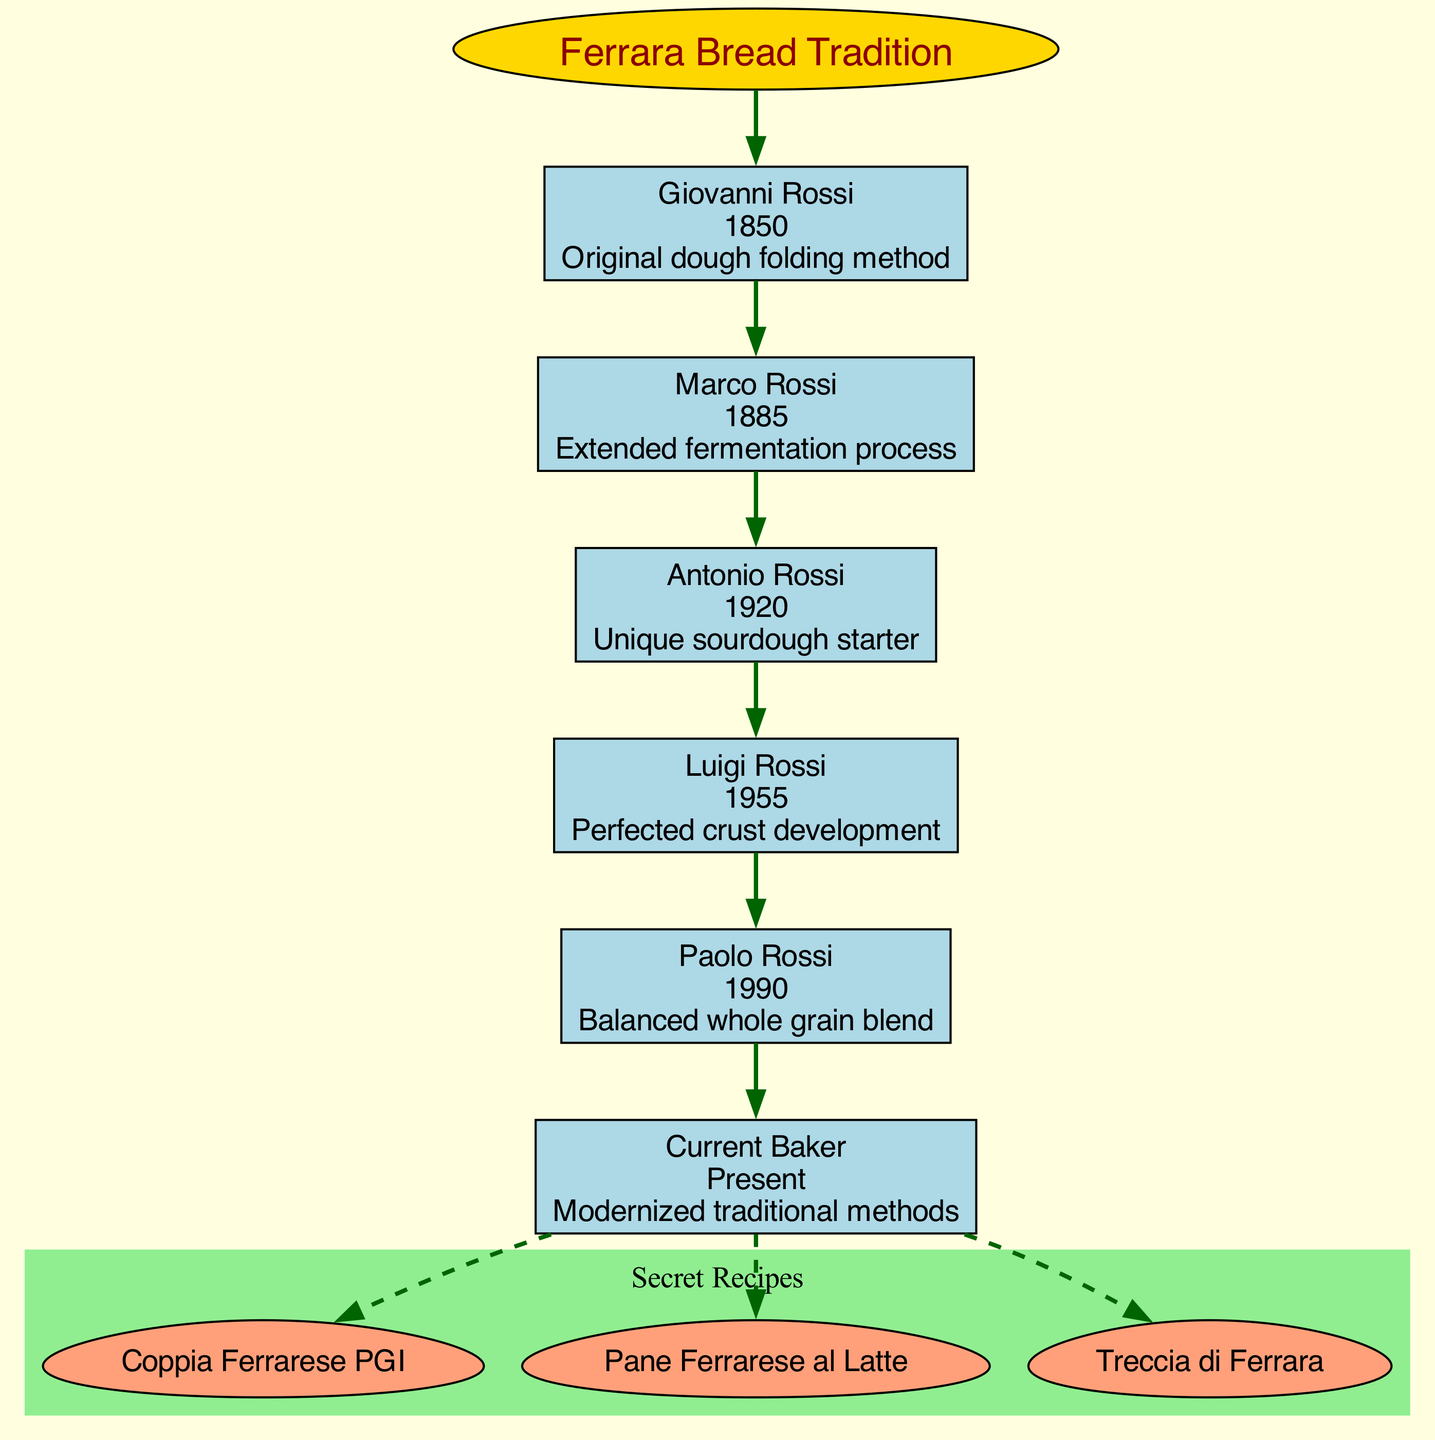What is the technique used by Giovanni Rossi? Giovanni Rossi is at the top of the lineage in the diagram, and the technique associated with him is "Original dough folding method."
Answer: Original dough folding method What year did Marco Rossi contribute his technique? By examining the node for Marco Rossi, it indicates that he contributed his technique in the year 1885.
Answer: 1885 How many secret recipes are listed in the diagram? The diagram includes three secret recipes underneath the "Secret Recipes" cluster, which can be counted visually.
Answer: 3 Which technique was perfected by Luigi Rossi? Luigi Rossi's node indicates that he perfected the technique named "Perfected crust development."
Answer: Perfected crust development Who is the current baker? The diagram identifies the last node as "Current Baker," which directly denotes the individual holding that title in the lineage.
Answer: Current Baker What technique follows the one developed by Antonio Rossi? The lineage shows that Luigi Rossi follows Antonio Rossi, and the technique associated with him is listed in the diagram.
Answer: Perfected crust development What year is associated with the "Balanced whole grain blend" technique? Looking at Paolo Rossi's node, it specifies that the year associated with the "Balanced whole grain blend" technique is 1990.
Answer: 1990 Which recipe is linked to the last generation represented in the diagram? The last generation, which is the Current Baker, has dashed lines leading to the secret recipes. By examining the connections, the first recipe linked is "Coppia Ferrarese PGI."
Answer: Coppia Ferrarese PGI Which baker introduced the unique sourdough starter? By finding Antonio Rossi in the lineage, it’s clear from his technique that he introduced the "Unique sourdough starter."
Answer: Antonio Rossi 